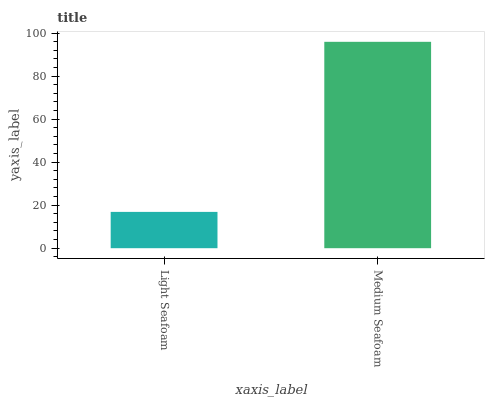Is Light Seafoam the minimum?
Answer yes or no. Yes. Is Medium Seafoam the maximum?
Answer yes or no. Yes. Is Medium Seafoam the minimum?
Answer yes or no. No. Is Medium Seafoam greater than Light Seafoam?
Answer yes or no. Yes. Is Light Seafoam less than Medium Seafoam?
Answer yes or no. Yes. Is Light Seafoam greater than Medium Seafoam?
Answer yes or no. No. Is Medium Seafoam less than Light Seafoam?
Answer yes or no. No. Is Medium Seafoam the high median?
Answer yes or no. Yes. Is Light Seafoam the low median?
Answer yes or no. Yes. Is Light Seafoam the high median?
Answer yes or no. No. Is Medium Seafoam the low median?
Answer yes or no. No. 